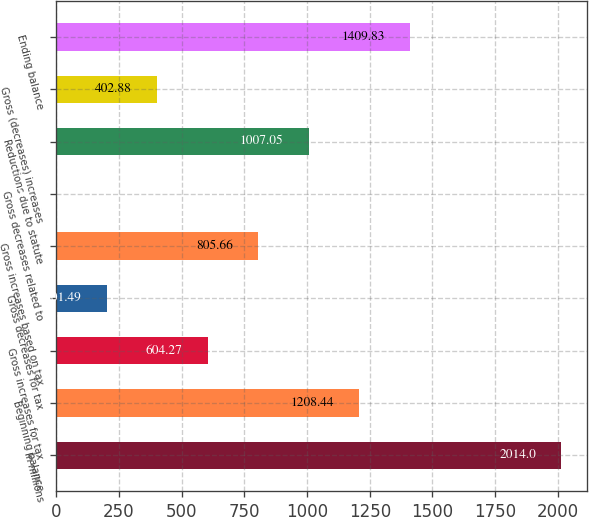<chart> <loc_0><loc_0><loc_500><loc_500><bar_chart><fcel>In millions<fcel>Beginning balance<fcel>Gross increases for tax<fcel>Gross decreases for tax<fcel>Gross increases based on tax<fcel>Gross decreases related to<fcel>Reductions due to statute<fcel>Gross (decreases) increases<fcel>Ending balance<nl><fcel>2014<fcel>1208.44<fcel>604.27<fcel>201.49<fcel>805.66<fcel>0.1<fcel>1007.05<fcel>402.88<fcel>1409.83<nl></chart> 